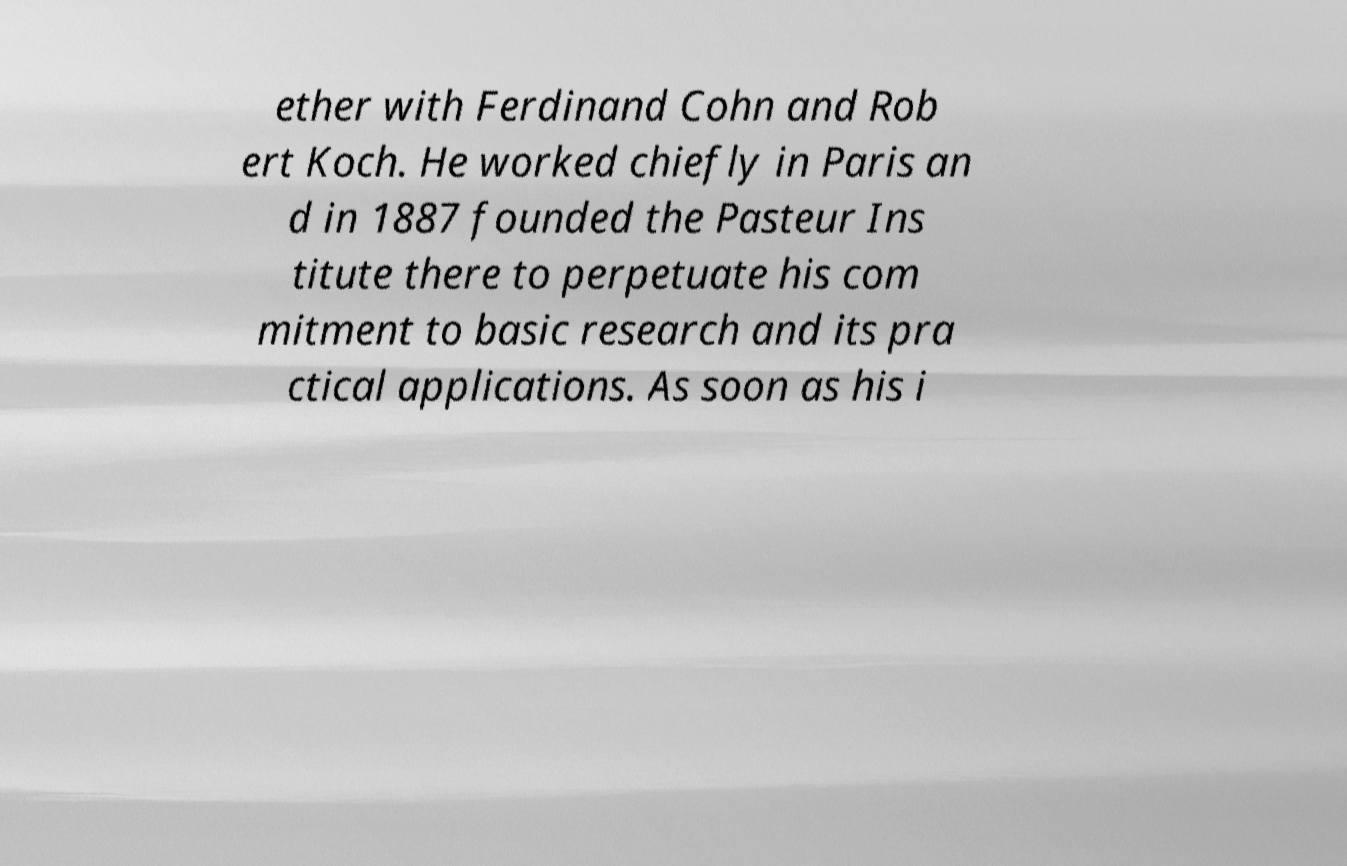Could you extract and type out the text from this image? ether with Ferdinand Cohn and Rob ert Koch. He worked chiefly in Paris an d in 1887 founded the Pasteur Ins titute there to perpetuate his com mitment to basic research and its pra ctical applications. As soon as his i 